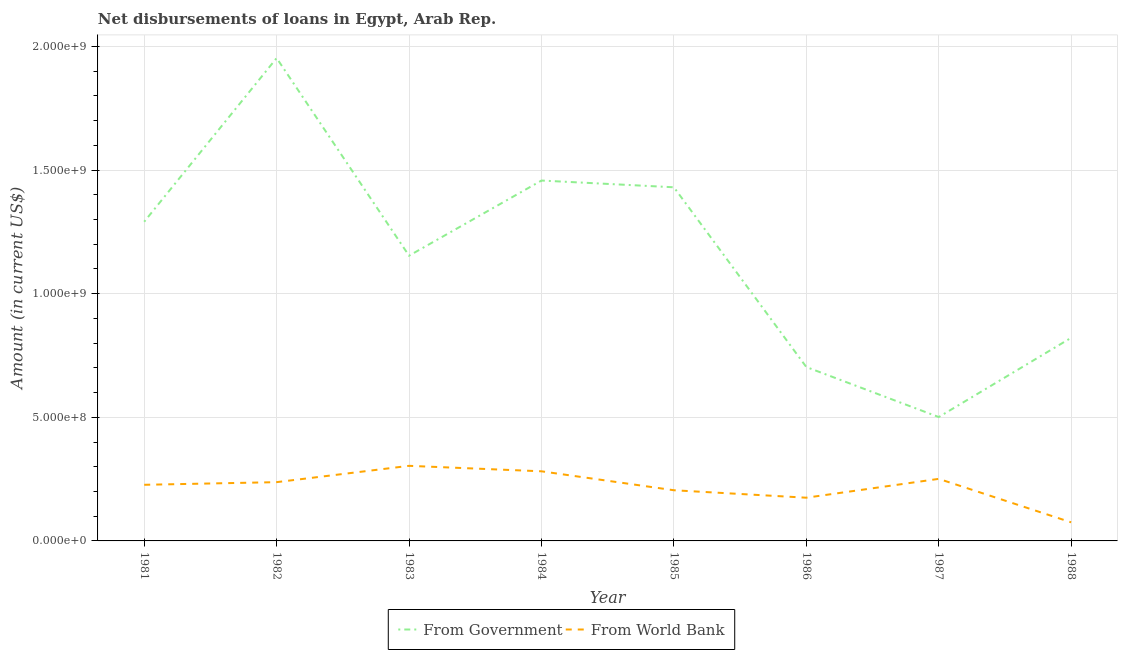Does the line corresponding to net disbursements of loan from government intersect with the line corresponding to net disbursements of loan from world bank?
Keep it short and to the point. No. Is the number of lines equal to the number of legend labels?
Offer a terse response. Yes. What is the net disbursements of loan from world bank in 1983?
Provide a succinct answer. 3.04e+08. Across all years, what is the maximum net disbursements of loan from world bank?
Your answer should be compact. 3.04e+08. Across all years, what is the minimum net disbursements of loan from world bank?
Give a very brief answer. 7.52e+07. In which year was the net disbursements of loan from world bank maximum?
Your answer should be very brief. 1983. What is the total net disbursements of loan from world bank in the graph?
Keep it short and to the point. 1.76e+09. What is the difference between the net disbursements of loan from world bank in 1984 and that in 1985?
Your response must be concise. 7.66e+07. What is the difference between the net disbursements of loan from world bank in 1986 and the net disbursements of loan from government in 1982?
Offer a very short reply. -1.78e+09. What is the average net disbursements of loan from government per year?
Make the answer very short. 1.16e+09. In the year 1986, what is the difference between the net disbursements of loan from government and net disbursements of loan from world bank?
Your answer should be very brief. 5.29e+08. In how many years, is the net disbursements of loan from government greater than 800000000 US$?
Ensure brevity in your answer.  6. What is the ratio of the net disbursements of loan from world bank in 1982 to that in 1987?
Provide a short and direct response. 0.95. Is the difference between the net disbursements of loan from world bank in 1982 and 1988 greater than the difference between the net disbursements of loan from government in 1982 and 1988?
Your answer should be compact. No. What is the difference between the highest and the second highest net disbursements of loan from world bank?
Ensure brevity in your answer.  2.21e+07. What is the difference between the highest and the lowest net disbursements of loan from world bank?
Provide a short and direct response. 2.28e+08. Is the sum of the net disbursements of loan from world bank in 1983 and 1987 greater than the maximum net disbursements of loan from government across all years?
Provide a succinct answer. No. Does the net disbursements of loan from government monotonically increase over the years?
Provide a succinct answer. No. Is the net disbursements of loan from government strictly greater than the net disbursements of loan from world bank over the years?
Make the answer very short. Yes. How many years are there in the graph?
Give a very brief answer. 8. What is the difference between two consecutive major ticks on the Y-axis?
Offer a terse response. 5.00e+08. How many legend labels are there?
Your response must be concise. 2. What is the title of the graph?
Make the answer very short. Net disbursements of loans in Egypt, Arab Rep. Does "Study and work" appear as one of the legend labels in the graph?
Your answer should be compact. No. What is the Amount (in current US$) of From Government in 1981?
Offer a very short reply. 1.29e+09. What is the Amount (in current US$) in From World Bank in 1981?
Offer a terse response. 2.27e+08. What is the Amount (in current US$) in From Government in 1982?
Provide a succinct answer. 1.95e+09. What is the Amount (in current US$) of From World Bank in 1982?
Your response must be concise. 2.38e+08. What is the Amount (in current US$) in From Government in 1983?
Make the answer very short. 1.15e+09. What is the Amount (in current US$) of From World Bank in 1983?
Ensure brevity in your answer.  3.04e+08. What is the Amount (in current US$) in From Government in 1984?
Offer a very short reply. 1.46e+09. What is the Amount (in current US$) in From World Bank in 1984?
Ensure brevity in your answer.  2.82e+08. What is the Amount (in current US$) of From Government in 1985?
Your answer should be compact. 1.43e+09. What is the Amount (in current US$) of From World Bank in 1985?
Your answer should be compact. 2.05e+08. What is the Amount (in current US$) of From Government in 1986?
Offer a very short reply. 7.03e+08. What is the Amount (in current US$) in From World Bank in 1986?
Ensure brevity in your answer.  1.75e+08. What is the Amount (in current US$) in From Government in 1987?
Your answer should be very brief. 5.01e+08. What is the Amount (in current US$) of From World Bank in 1987?
Provide a succinct answer. 2.51e+08. What is the Amount (in current US$) in From Government in 1988?
Your answer should be very brief. 8.21e+08. What is the Amount (in current US$) of From World Bank in 1988?
Give a very brief answer. 7.52e+07. Across all years, what is the maximum Amount (in current US$) in From Government?
Provide a short and direct response. 1.95e+09. Across all years, what is the maximum Amount (in current US$) in From World Bank?
Your answer should be very brief. 3.04e+08. Across all years, what is the minimum Amount (in current US$) of From Government?
Provide a short and direct response. 5.01e+08. Across all years, what is the minimum Amount (in current US$) in From World Bank?
Your answer should be compact. 7.52e+07. What is the total Amount (in current US$) of From Government in the graph?
Provide a short and direct response. 9.31e+09. What is the total Amount (in current US$) in From World Bank in the graph?
Provide a short and direct response. 1.76e+09. What is the difference between the Amount (in current US$) in From Government in 1981 and that in 1982?
Provide a succinct answer. -6.62e+08. What is the difference between the Amount (in current US$) of From World Bank in 1981 and that in 1982?
Give a very brief answer. -1.07e+07. What is the difference between the Amount (in current US$) in From Government in 1981 and that in 1983?
Make the answer very short. 1.37e+08. What is the difference between the Amount (in current US$) of From World Bank in 1981 and that in 1983?
Your answer should be very brief. -7.67e+07. What is the difference between the Amount (in current US$) of From Government in 1981 and that in 1984?
Offer a terse response. -1.67e+08. What is the difference between the Amount (in current US$) of From World Bank in 1981 and that in 1984?
Your response must be concise. -5.46e+07. What is the difference between the Amount (in current US$) in From Government in 1981 and that in 1985?
Offer a terse response. -1.39e+08. What is the difference between the Amount (in current US$) in From World Bank in 1981 and that in 1985?
Ensure brevity in your answer.  2.20e+07. What is the difference between the Amount (in current US$) of From Government in 1981 and that in 1986?
Your response must be concise. 5.88e+08. What is the difference between the Amount (in current US$) in From World Bank in 1981 and that in 1986?
Provide a succinct answer. 5.22e+07. What is the difference between the Amount (in current US$) of From Government in 1981 and that in 1987?
Give a very brief answer. 7.90e+08. What is the difference between the Amount (in current US$) in From World Bank in 1981 and that in 1987?
Keep it short and to the point. -2.40e+07. What is the difference between the Amount (in current US$) in From Government in 1981 and that in 1988?
Keep it short and to the point. 4.69e+08. What is the difference between the Amount (in current US$) of From World Bank in 1981 and that in 1988?
Your answer should be very brief. 1.52e+08. What is the difference between the Amount (in current US$) of From Government in 1982 and that in 1983?
Offer a very short reply. 7.99e+08. What is the difference between the Amount (in current US$) of From World Bank in 1982 and that in 1983?
Give a very brief answer. -6.60e+07. What is the difference between the Amount (in current US$) of From Government in 1982 and that in 1984?
Your answer should be compact. 4.95e+08. What is the difference between the Amount (in current US$) of From World Bank in 1982 and that in 1984?
Offer a very short reply. -4.39e+07. What is the difference between the Amount (in current US$) of From Government in 1982 and that in 1985?
Your response must be concise. 5.23e+08. What is the difference between the Amount (in current US$) in From World Bank in 1982 and that in 1985?
Provide a short and direct response. 3.27e+07. What is the difference between the Amount (in current US$) in From Government in 1982 and that in 1986?
Ensure brevity in your answer.  1.25e+09. What is the difference between the Amount (in current US$) of From World Bank in 1982 and that in 1986?
Your response must be concise. 6.29e+07. What is the difference between the Amount (in current US$) of From Government in 1982 and that in 1987?
Offer a very short reply. 1.45e+09. What is the difference between the Amount (in current US$) in From World Bank in 1982 and that in 1987?
Offer a terse response. -1.33e+07. What is the difference between the Amount (in current US$) of From Government in 1982 and that in 1988?
Make the answer very short. 1.13e+09. What is the difference between the Amount (in current US$) in From World Bank in 1982 and that in 1988?
Ensure brevity in your answer.  1.62e+08. What is the difference between the Amount (in current US$) in From Government in 1983 and that in 1984?
Your answer should be very brief. -3.04e+08. What is the difference between the Amount (in current US$) of From World Bank in 1983 and that in 1984?
Your answer should be very brief. 2.21e+07. What is the difference between the Amount (in current US$) in From Government in 1983 and that in 1985?
Provide a succinct answer. -2.77e+08. What is the difference between the Amount (in current US$) of From World Bank in 1983 and that in 1985?
Make the answer very short. 9.87e+07. What is the difference between the Amount (in current US$) of From Government in 1983 and that in 1986?
Give a very brief answer. 4.50e+08. What is the difference between the Amount (in current US$) of From World Bank in 1983 and that in 1986?
Your answer should be compact. 1.29e+08. What is the difference between the Amount (in current US$) in From Government in 1983 and that in 1987?
Your answer should be very brief. 6.53e+08. What is the difference between the Amount (in current US$) of From World Bank in 1983 and that in 1987?
Keep it short and to the point. 5.27e+07. What is the difference between the Amount (in current US$) of From Government in 1983 and that in 1988?
Offer a very short reply. 3.32e+08. What is the difference between the Amount (in current US$) in From World Bank in 1983 and that in 1988?
Your answer should be very brief. 2.28e+08. What is the difference between the Amount (in current US$) of From Government in 1984 and that in 1985?
Your response must be concise. 2.73e+07. What is the difference between the Amount (in current US$) of From World Bank in 1984 and that in 1985?
Ensure brevity in your answer.  7.66e+07. What is the difference between the Amount (in current US$) of From Government in 1984 and that in 1986?
Your answer should be very brief. 7.54e+08. What is the difference between the Amount (in current US$) in From World Bank in 1984 and that in 1986?
Your response must be concise. 1.07e+08. What is the difference between the Amount (in current US$) of From Government in 1984 and that in 1987?
Give a very brief answer. 9.57e+08. What is the difference between the Amount (in current US$) in From World Bank in 1984 and that in 1987?
Your answer should be very brief. 3.06e+07. What is the difference between the Amount (in current US$) in From Government in 1984 and that in 1988?
Ensure brevity in your answer.  6.36e+08. What is the difference between the Amount (in current US$) in From World Bank in 1984 and that in 1988?
Your answer should be very brief. 2.06e+08. What is the difference between the Amount (in current US$) in From Government in 1985 and that in 1986?
Your answer should be very brief. 7.27e+08. What is the difference between the Amount (in current US$) of From World Bank in 1985 and that in 1986?
Keep it short and to the point. 3.02e+07. What is the difference between the Amount (in current US$) in From Government in 1985 and that in 1987?
Your response must be concise. 9.29e+08. What is the difference between the Amount (in current US$) of From World Bank in 1985 and that in 1987?
Offer a terse response. -4.60e+07. What is the difference between the Amount (in current US$) in From Government in 1985 and that in 1988?
Provide a succinct answer. 6.09e+08. What is the difference between the Amount (in current US$) in From World Bank in 1985 and that in 1988?
Keep it short and to the point. 1.30e+08. What is the difference between the Amount (in current US$) in From Government in 1986 and that in 1987?
Provide a short and direct response. 2.02e+08. What is the difference between the Amount (in current US$) in From World Bank in 1986 and that in 1987?
Provide a succinct answer. -7.62e+07. What is the difference between the Amount (in current US$) in From Government in 1986 and that in 1988?
Offer a terse response. -1.18e+08. What is the difference between the Amount (in current US$) of From World Bank in 1986 and that in 1988?
Make the answer very short. 9.96e+07. What is the difference between the Amount (in current US$) in From Government in 1987 and that in 1988?
Ensure brevity in your answer.  -3.20e+08. What is the difference between the Amount (in current US$) in From World Bank in 1987 and that in 1988?
Provide a short and direct response. 1.76e+08. What is the difference between the Amount (in current US$) of From Government in 1981 and the Amount (in current US$) of From World Bank in 1982?
Keep it short and to the point. 1.05e+09. What is the difference between the Amount (in current US$) in From Government in 1981 and the Amount (in current US$) in From World Bank in 1983?
Give a very brief answer. 9.87e+08. What is the difference between the Amount (in current US$) of From Government in 1981 and the Amount (in current US$) of From World Bank in 1984?
Your answer should be very brief. 1.01e+09. What is the difference between the Amount (in current US$) of From Government in 1981 and the Amount (in current US$) of From World Bank in 1985?
Offer a very short reply. 1.09e+09. What is the difference between the Amount (in current US$) of From Government in 1981 and the Amount (in current US$) of From World Bank in 1986?
Keep it short and to the point. 1.12e+09. What is the difference between the Amount (in current US$) of From Government in 1981 and the Amount (in current US$) of From World Bank in 1987?
Provide a succinct answer. 1.04e+09. What is the difference between the Amount (in current US$) of From Government in 1981 and the Amount (in current US$) of From World Bank in 1988?
Provide a short and direct response. 1.22e+09. What is the difference between the Amount (in current US$) of From Government in 1982 and the Amount (in current US$) of From World Bank in 1983?
Offer a terse response. 1.65e+09. What is the difference between the Amount (in current US$) in From Government in 1982 and the Amount (in current US$) in From World Bank in 1984?
Give a very brief answer. 1.67e+09. What is the difference between the Amount (in current US$) of From Government in 1982 and the Amount (in current US$) of From World Bank in 1985?
Offer a terse response. 1.75e+09. What is the difference between the Amount (in current US$) of From Government in 1982 and the Amount (in current US$) of From World Bank in 1986?
Your response must be concise. 1.78e+09. What is the difference between the Amount (in current US$) in From Government in 1982 and the Amount (in current US$) in From World Bank in 1987?
Offer a very short reply. 1.70e+09. What is the difference between the Amount (in current US$) in From Government in 1982 and the Amount (in current US$) in From World Bank in 1988?
Ensure brevity in your answer.  1.88e+09. What is the difference between the Amount (in current US$) of From Government in 1983 and the Amount (in current US$) of From World Bank in 1984?
Your response must be concise. 8.72e+08. What is the difference between the Amount (in current US$) of From Government in 1983 and the Amount (in current US$) of From World Bank in 1985?
Provide a succinct answer. 9.49e+08. What is the difference between the Amount (in current US$) of From Government in 1983 and the Amount (in current US$) of From World Bank in 1986?
Make the answer very short. 9.79e+08. What is the difference between the Amount (in current US$) in From Government in 1983 and the Amount (in current US$) in From World Bank in 1987?
Keep it short and to the point. 9.03e+08. What is the difference between the Amount (in current US$) in From Government in 1983 and the Amount (in current US$) in From World Bank in 1988?
Ensure brevity in your answer.  1.08e+09. What is the difference between the Amount (in current US$) in From Government in 1984 and the Amount (in current US$) in From World Bank in 1985?
Your answer should be very brief. 1.25e+09. What is the difference between the Amount (in current US$) in From Government in 1984 and the Amount (in current US$) in From World Bank in 1986?
Provide a succinct answer. 1.28e+09. What is the difference between the Amount (in current US$) of From Government in 1984 and the Amount (in current US$) of From World Bank in 1987?
Keep it short and to the point. 1.21e+09. What is the difference between the Amount (in current US$) in From Government in 1984 and the Amount (in current US$) in From World Bank in 1988?
Offer a very short reply. 1.38e+09. What is the difference between the Amount (in current US$) of From Government in 1985 and the Amount (in current US$) of From World Bank in 1986?
Provide a short and direct response. 1.26e+09. What is the difference between the Amount (in current US$) of From Government in 1985 and the Amount (in current US$) of From World Bank in 1987?
Keep it short and to the point. 1.18e+09. What is the difference between the Amount (in current US$) of From Government in 1985 and the Amount (in current US$) of From World Bank in 1988?
Provide a short and direct response. 1.36e+09. What is the difference between the Amount (in current US$) in From Government in 1986 and the Amount (in current US$) in From World Bank in 1987?
Make the answer very short. 4.52e+08. What is the difference between the Amount (in current US$) in From Government in 1986 and the Amount (in current US$) in From World Bank in 1988?
Keep it short and to the point. 6.28e+08. What is the difference between the Amount (in current US$) in From Government in 1987 and the Amount (in current US$) in From World Bank in 1988?
Offer a terse response. 4.26e+08. What is the average Amount (in current US$) in From Government per year?
Make the answer very short. 1.16e+09. What is the average Amount (in current US$) of From World Bank per year?
Provide a short and direct response. 2.19e+08. In the year 1981, what is the difference between the Amount (in current US$) in From Government and Amount (in current US$) in From World Bank?
Ensure brevity in your answer.  1.06e+09. In the year 1982, what is the difference between the Amount (in current US$) of From Government and Amount (in current US$) of From World Bank?
Offer a terse response. 1.72e+09. In the year 1983, what is the difference between the Amount (in current US$) in From Government and Amount (in current US$) in From World Bank?
Keep it short and to the point. 8.50e+08. In the year 1984, what is the difference between the Amount (in current US$) of From Government and Amount (in current US$) of From World Bank?
Give a very brief answer. 1.18e+09. In the year 1985, what is the difference between the Amount (in current US$) of From Government and Amount (in current US$) of From World Bank?
Keep it short and to the point. 1.23e+09. In the year 1986, what is the difference between the Amount (in current US$) of From Government and Amount (in current US$) of From World Bank?
Your answer should be very brief. 5.29e+08. In the year 1987, what is the difference between the Amount (in current US$) in From Government and Amount (in current US$) in From World Bank?
Your answer should be very brief. 2.50e+08. In the year 1988, what is the difference between the Amount (in current US$) in From Government and Amount (in current US$) in From World Bank?
Your answer should be very brief. 7.46e+08. What is the ratio of the Amount (in current US$) in From Government in 1981 to that in 1982?
Make the answer very short. 0.66. What is the ratio of the Amount (in current US$) of From World Bank in 1981 to that in 1982?
Ensure brevity in your answer.  0.95. What is the ratio of the Amount (in current US$) of From Government in 1981 to that in 1983?
Offer a terse response. 1.12. What is the ratio of the Amount (in current US$) of From World Bank in 1981 to that in 1983?
Your answer should be very brief. 0.75. What is the ratio of the Amount (in current US$) of From Government in 1981 to that in 1984?
Make the answer very short. 0.89. What is the ratio of the Amount (in current US$) in From World Bank in 1981 to that in 1984?
Offer a terse response. 0.81. What is the ratio of the Amount (in current US$) in From Government in 1981 to that in 1985?
Make the answer very short. 0.9. What is the ratio of the Amount (in current US$) of From World Bank in 1981 to that in 1985?
Ensure brevity in your answer.  1.11. What is the ratio of the Amount (in current US$) of From Government in 1981 to that in 1986?
Your answer should be very brief. 1.84. What is the ratio of the Amount (in current US$) in From World Bank in 1981 to that in 1986?
Offer a terse response. 1.3. What is the ratio of the Amount (in current US$) of From Government in 1981 to that in 1987?
Your response must be concise. 2.58. What is the ratio of the Amount (in current US$) of From World Bank in 1981 to that in 1987?
Give a very brief answer. 0.9. What is the ratio of the Amount (in current US$) of From Government in 1981 to that in 1988?
Ensure brevity in your answer.  1.57. What is the ratio of the Amount (in current US$) of From World Bank in 1981 to that in 1988?
Make the answer very short. 3.02. What is the ratio of the Amount (in current US$) of From Government in 1982 to that in 1983?
Offer a very short reply. 1.69. What is the ratio of the Amount (in current US$) of From World Bank in 1982 to that in 1983?
Offer a terse response. 0.78. What is the ratio of the Amount (in current US$) in From Government in 1982 to that in 1984?
Provide a succinct answer. 1.34. What is the ratio of the Amount (in current US$) in From World Bank in 1982 to that in 1984?
Make the answer very short. 0.84. What is the ratio of the Amount (in current US$) in From Government in 1982 to that in 1985?
Provide a short and direct response. 1.37. What is the ratio of the Amount (in current US$) in From World Bank in 1982 to that in 1985?
Your answer should be very brief. 1.16. What is the ratio of the Amount (in current US$) in From Government in 1982 to that in 1986?
Your response must be concise. 2.78. What is the ratio of the Amount (in current US$) of From World Bank in 1982 to that in 1986?
Provide a succinct answer. 1.36. What is the ratio of the Amount (in current US$) of From Government in 1982 to that in 1987?
Make the answer very short. 3.9. What is the ratio of the Amount (in current US$) of From World Bank in 1982 to that in 1987?
Make the answer very short. 0.95. What is the ratio of the Amount (in current US$) of From Government in 1982 to that in 1988?
Provide a succinct answer. 2.38. What is the ratio of the Amount (in current US$) of From World Bank in 1982 to that in 1988?
Offer a very short reply. 3.16. What is the ratio of the Amount (in current US$) in From Government in 1983 to that in 1984?
Your answer should be compact. 0.79. What is the ratio of the Amount (in current US$) of From World Bank in 1983 to that in 1984?
Make the answer very short. 1.08. What is the ratio of the Amount (in current US$) in From Government in 1983 to that in 1985?
Ensure brevity in your answer.  0.81. What is the ratio of the Amount (in current US$) of From World Bank in 1983 to that in 1985?
Keep it short and to the point. 1.48. What is the ratio of the Amount (in current US$) in From Government in 1983 to that in 1986?
Give a very brief answer. 1.64. What is the ratio of the Amount (in current US$) of From World Bank in 1983 to that in 1986?
Keep it short and to the point. 1.74. What is the ratio of the Amount (in current US$) in From Government in 1983 to that in 1987?
Offer a very short reply. 2.3. What is the ratio of the Amount (in current US$) in From World Bank in 1983 to that in 1987?
Provide a short and direct response. 1.21. What is the ratio of the Amount (in current US$) of From Government in 1983 to that in 1988?
Provide a succinct answer. 1.4. What is the ratio of the Amount (in current US$) in From World Bank in 1983 to that in 1988?
Provide a short and direct response. 4.04. What is the ratio of the Amount (in current US$) in From Government in 1984 to that in 1985?
Your answer should be compact. 1.02. What is the ratio of the Amount (in current US$) in From World Bank in 1984 to that in 1985?
Your answer should be compact. 1.37. What is the ratio of the Amount (in current US$) in From Government in 1984 to that in 1986?
Offer a terse response. 2.07. What is the ratio of the Amount (in current US$) in From World Bank in 1984 to that in 1986?
Your response must be concise. 1.61. What is the ratio of the Amount (in current US$) in From Government in 1984 to that in 1987?
Provide a short and direct response. 2.91. What is the ratio of the Amount (in current US$) in From World Bank in 1984 to that in 1987?
Provide a short and direct response. 1.12. What is the ratio of the Amount (in current US$) of From Government in 1984 to that in 1988?
Your response must be concise. 1.77. What is the ratio of the Amount (in current US$) in From World Bank in 1984 to that in 1988?
Ensure brevity in your answer.  3.74. What is the ratio of the Amount (in current US$) in From Government in 1985 to that in 1986?
Give a very brief answer. 2.03. What is the ratio of the Amount (in current US$) in From World Bank in 1985 to that in 1986?
Make the answer very short. 1.17. What is the ratio of the Amount (in current US$) of From Government in 1985 to that in 1987?
Your answer should be compact. 2.85. What is the ratio of the Amount (in current US$) of From World Bank in 1985 to that in 1987?
Offer a terse response. 0.82. What is the ratio of the Amount (in current US$) of From Government in 1985 to that in 1988?
Provide a short and direct response. 1.74. What is the ratio of the Amount (in current US$) of From World Bank in 1985 to that in 1988?
Your answer should be very brief. 2.72. What is the ratio of the Amount (in current US$) in From Government in 1986 to that in 1987?
Offer a very short reply. 1.4. What is the ratio of the Amount (in current US$) of From World Bank in 1986 to that in 1987?
Make the answer very short. 0.7. What is the ratio of the Amount (in current US$) in From Government in 1986 to that in 1988?
Make the answer very short. 0.86. What is the ratio of the Amount (in current US$) of From World Bank in 1986 to that in 1988?
Ensure brevity in your answer.  2.32. What is the ratio of the Amount (in current US$) in From Government in 1987 to that in 1988?
Provide a succinct answer. 0.61. What is the ratio of the Amount (in current US$) in From World Bank in 1987 to that in 1988?
Your response must be concise. 3.34. What is the difference between the highest and the second highest Amount (in current US$) of From Government?
Your answer should be compact. 4.95e+08. What is the difference between the highest and the second highest Amount (in current US$) in From World Bank?
Keep it short and to the point. 2.21e+07. What is the difference between the highest and the lowest Amount (in current US$) in From Government?
Make the answer very short. 1.45e+09. What is the difference between the highest and the lowest Amount (in current US$) of From World Bank?
Provide a succinct answer. 2.28e+08. 